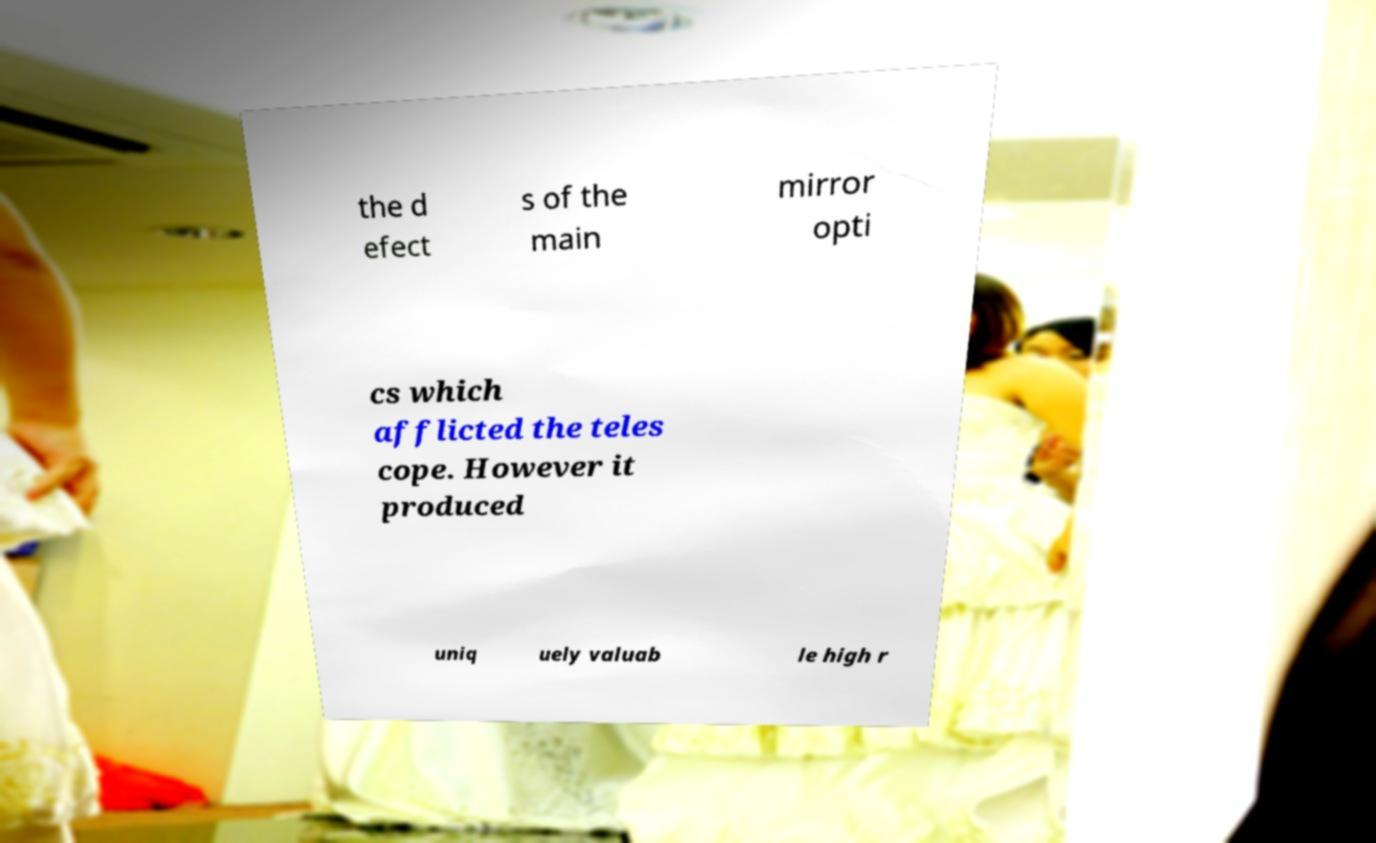What messages or text are displayed in this image? I need them in a readable, typed format. the d efect s of the main mirror opti cs which afflicted the teles cope. However it produced uniq uely valuab le high r 